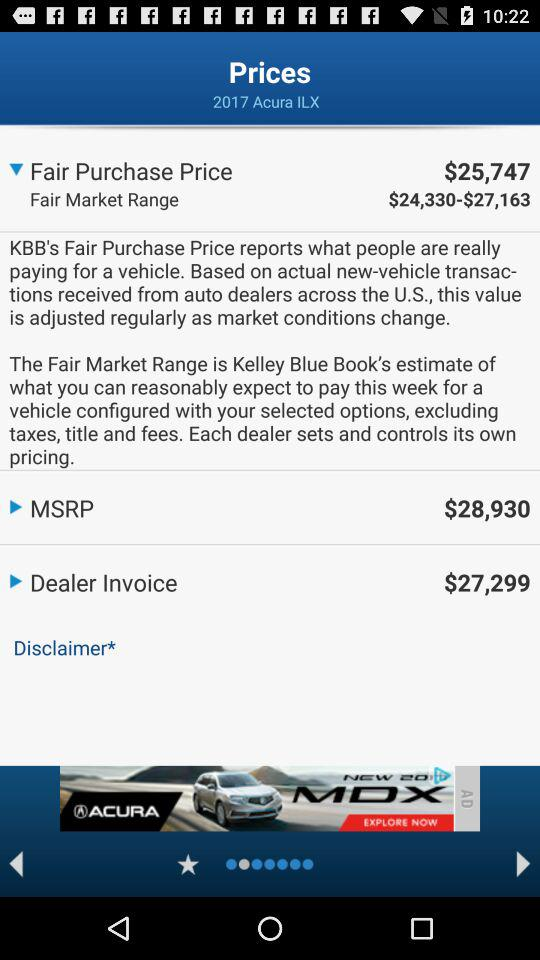What is the fair market range? The fair market range is $24,330 to $27,163. 